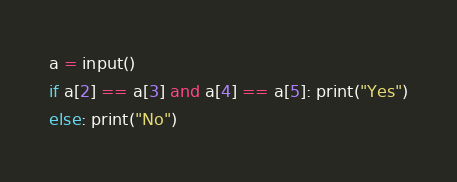Convert code to text. <code><loc_0><loc_0><loc_500><loc_500><_Python_>a = input()
if a[2] == a[3] and a[4] == a[5]: print("Yes")
else: print("No")</code> 